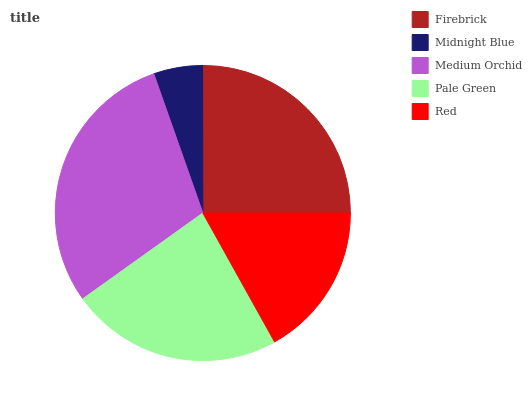Is Midnight Blue the minimum?
Answer yes or no. Yes. Is Medium Orchid the maximum?
Answer yes or no. Yes. Is Medium Orchid the minimum?
Answer yes or no. No. Is Midnight Blue the maximum?
Answer yes or no. No. Is Medium Orchid greater than Midnight Blue?
Answer yes or no. Yes. Is Midnight Blue less than Medium Orchid?
Answer yes or no. Yes. Is Midnight Blue greater than Medium Orchid?
Answer yes or no. No. Is Medium Orchid less than Midnight Blue?
Answer yes or no. No. Is Pale Green the high median?
Answer yes or no. Yes. Is Pale Green the low median?
Answer yes or no. Yes. Is Red the high median?
Answer yes or no. No. Is Midnight Blue the low median?
Answer yes or no. No. 